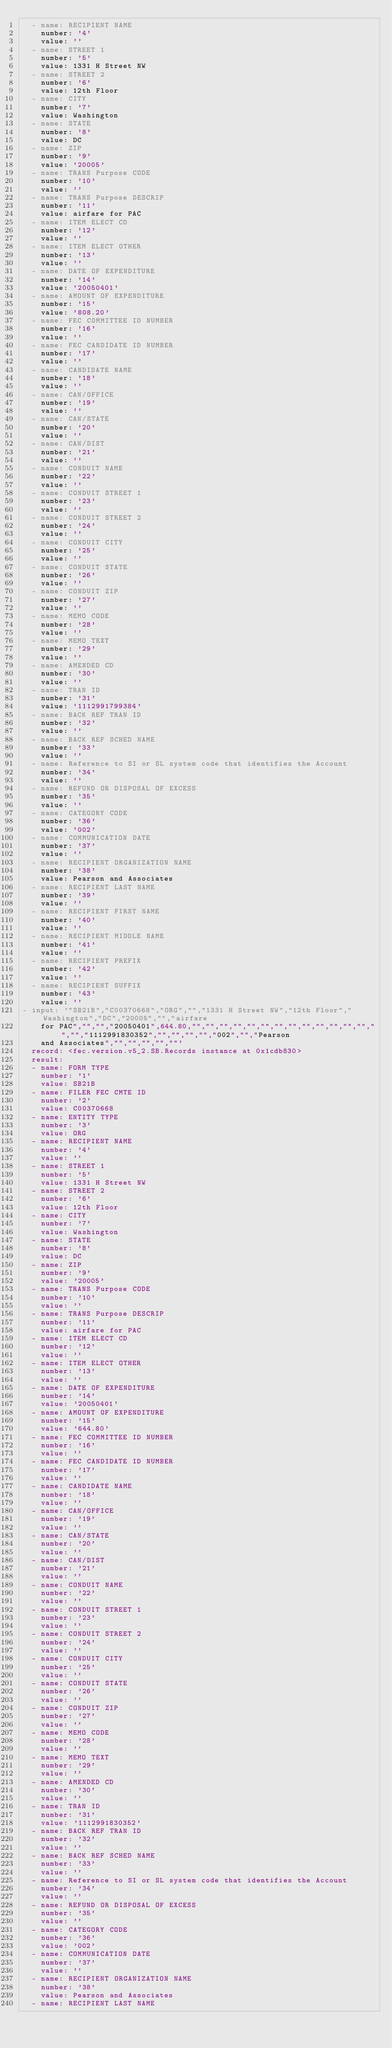Convert code to text. <code><loc_0><loc_0><loc_500><loc_500><_YAML_>  - name: RECIPIENT NAME
    number: '4'
    value: ''
  - name: STREET 1
    number: '5'
    value: 1331 H Street NW
  - name: STREET 2
    number: '6'
    value: 12th Floor
  - name: CITY
    number: '7'
    value: Washington
  - name: STATE
    number: '8'
    value: DC
  - name: ZIP
    number: '9'
    value: '20005'
  - name: TRANS Purpose CODE
    number: '10'
    value: ''
  - name: TRANS Purpose DESCRIP
    number: '11'
    value: airfare for PAC
  - name: ITEM ELECT CD
    number: '12'
    value: ''
  - name: ITEM ELECT OTHER
    number: '13'
    value: ''
  - name: DATE OF EXPENDITURE
    number: '14'
    value: '20050401'
  - name: AMOUNT OF EXPENDITURE
    number: '15'
    value: '808.20'
  - name: FEC COMMITTEE ID NUMBER
    number: '16'
    value: ''
  - name: FEC CANDIDATE ID NUMBER
    number: '17'
    value: ''
  - name: CANDIDATE NAME
    number: '18'
    value: ''
  - name: CAN/OFFICE
    number: '19'
    value: ''
  - name: CAN/STATE
    number: '20'
    value: ''
  - name: CAN/DIST
    number: '21'
    value: ''
  - name: CONDUIT NAME
    number: '22'
    value: ''
  - name: CONDUIT STREET 1
    number: '23'
    value: ''
  - name: CONDUIT STREET 2
    number: '24'
    value: ''
  - name: CONDUIT CITY
    number: '25'
    value: ''
  - name: CONDUIT STATE
    number: '26'
    value: ''
  - name: CONDUIT ZIP
    number: '27'
    value: ''
  - name: MEMO CODE
    number: '28'
    value: ''
  - name: MEMO TEXT
    number: '29'
    value: ''
  - name: AMENDED CD
    number: '30'
    value: ''
  - name: TRAN ID
    number: '31'
    value: '1112991799384'
  - name: BACK REF TRAN ID
    number: '32'
    value: ''
  - name: BACK REF SCHED NAME
    number: '33'
    value: ''
  - name: Reference to SI or SL system code that identifies the Account
    number: '34'
    value: ''
  - name: REFUND OR DISPOSAL OF EXCESS
    number: '35'
    value: ''
  - name: CATEGORY CODE
    number: '36'
    value: '002'
  - name: COMMUNICATION DATE
    number: '37'
    value: ''
  - name: RECIPIENT ORGANIZATION NAME
    number: '38'
    value: Pearson and Associates
  - name: RECIPIENT LAST NAME
    number: '39'
    value: ''
  - name: RECIPIENT FIRST NAME
    number: '40'
    value: ''
  - name: RECIPIENT MIDDLE NAME
    number: '41'
    value: ''
  - name: RECIPIENT PREFIX
    number: '42'
    value: ''
  - name: RECIPIENT SUFFIX
    number: '43'
    value: ''
- input: '"SB21B","C00370668","ORG","","1331 H Street NW","12th Floor","Washington","DC","20005","","airfare
    for PAC","","","20050401",644.80,"","","","","","","","","","","","","","","","1112991830352","","","","","002","","Pearson
    and Associates","","","","",""'
  record: <fec.version.v5_2.SB.Records instance at 0x1cdb830>
  result:
  - name: FORM TYPE
    number: '1'
    value: SB21B
  - name: FILER FEC CMTE ID
    number: '2'
    value: C00370668
  - name: ENTITY TYPE
    number: '3'
    value: ORG
  - name: RECIPIENT NAME
    number: '4'
    value: ''
  - name: STREET 1
    number: '5'
    value: 1331 H Street NW
  - name: STREET 2
    number: '6'
    value: 12th Floor
  - name: CITY
    number: '7'
    value: Washington
  - name: STATE
    number: '8'
    value: DC
  - name: ZIP
    number: '9'
    value: '20005'
  - name: TRANS Purpose CODE
    number: '10'
    value: ''
  - name: TRANS Purpose DESCRIP
    number: '11'
    value: airfare for PAC
  - name: ITEM ELECT CD
    number: '12'
    value: ''
  - name: ITEM ELECT OTHER
    number: '13'
    value: ''
  - name: DATE OF EXPENDITURE
    number: '14'
    value: '20050401'
  - name: AMOUNT OF EXPENDITURE
    number: '15'
    value: '644.80'
  - name: FEC COMMITTEE ID NUMBER
    number: '16'
    value: ''
  - name: FEC CANDIDATE ID NUMBER
    number: '17'
    value: ''
  - name: CANDIDATE NAME
    number: '18'
    value: ''
  - name: CAN/OFFICE
    number: '19'
    value: ''
  - name: CAN/STATE
    number: '20'
    value: ''
  - name: CAN/DIST
    number: '21'
    value: ''
  - name: CONDUIT NAME
    number: '22'
    value: ''
  - name: CONDUIT STREET 1
    number: '23'
    value: ''
  - name: CONDUIT STREET 2
    number: '24'
    value: ''
  - name: CONDUIT CITY
    number: '25'
    value: ''
  - name: CONDUIT STATE
    number: '26'
    value: ''
  - name: CONDUIT ZIP
    number: '27'
    value: ''
  - name: MEMO CODE
    number: '28'
    value: ''
  - name: MEMO TEXT
    number: '29'
    value: ''
  - name: AMENDED CD
    number: '30'
    value: ''
  - name: TRAN ID
    number: '31'
    value: '1112991830352'
  - name: BACK REF TRAN ID
    number: '32'
    value: ''
  - name: BACK REF SCHED NAME
    number: '33'
    value: ''
  - name: Reference to SI or SL system code that identifies the Account
    number: '34'
    value: ''
  - name: REFUND OR DISPOSAL OF EXCESS
    number: '35'
    value: ''
  - name: CATEGORY CODE
    number: '36'
    value: '002'
  - name: COMMUNICATION DATE
    number: '37'
    value: ''
  - name: RECIPIENT ORGANIZATION NAME
    number: '38'
    value: Pearson and Associates
  - name: RECIPIENT LAST NAME</code> 